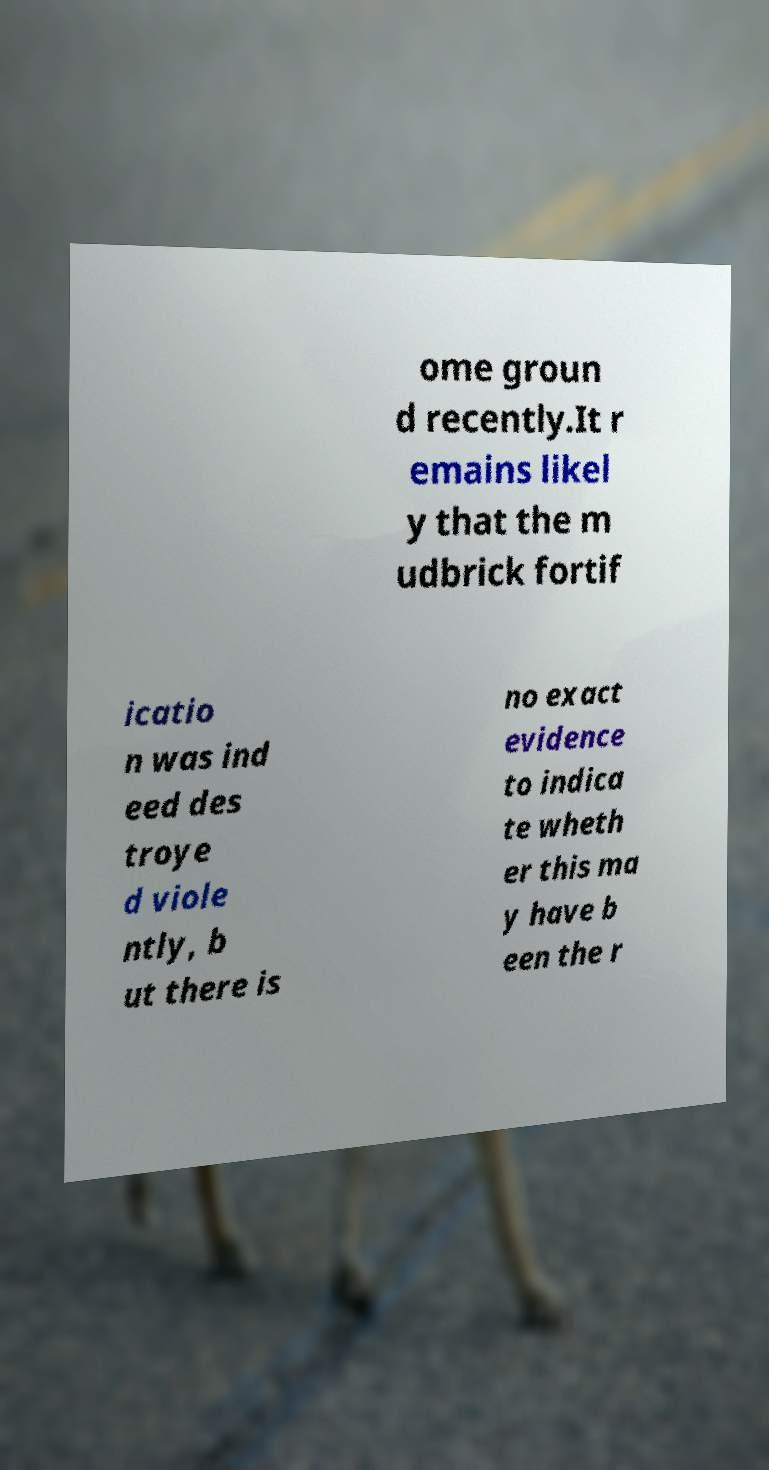Can you read and provide the text displayed in the image?This photo seems to have some interesting text. Can you extract and type it out for me? ome groun d recently.It r emains likel y that the m udbrick fortif icatio n was ind eed des troye d viole ntly, b ut there is no exact evidence to indica te wheth er this ma y have b een the r 